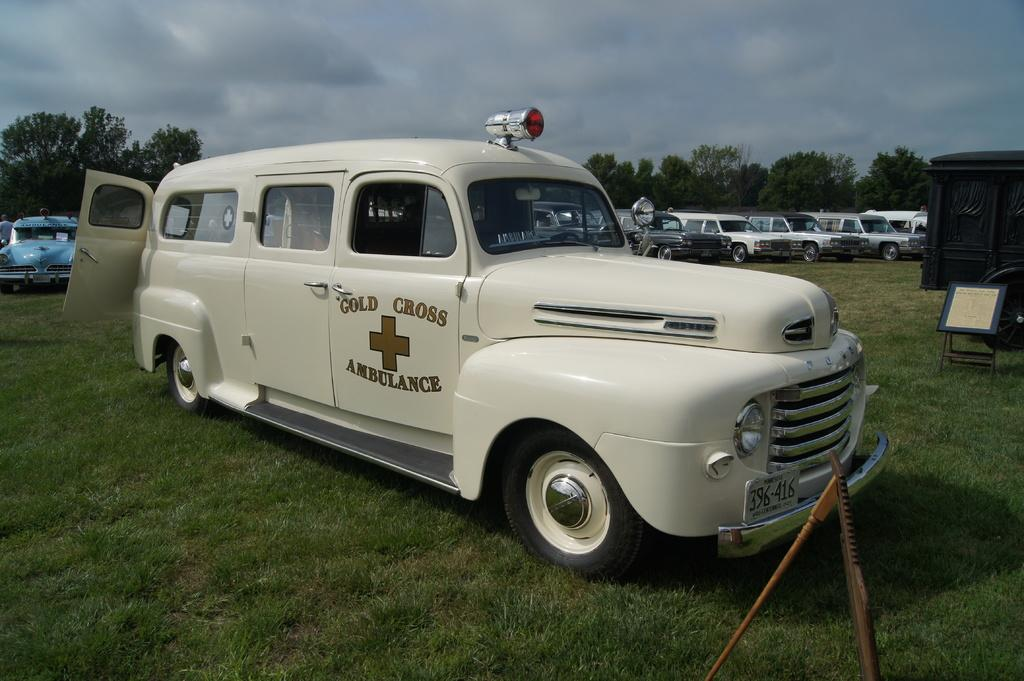<image>
Describe the image concisely. A white emergency vehicle with the letters, "gold cross ambulance" on it. 